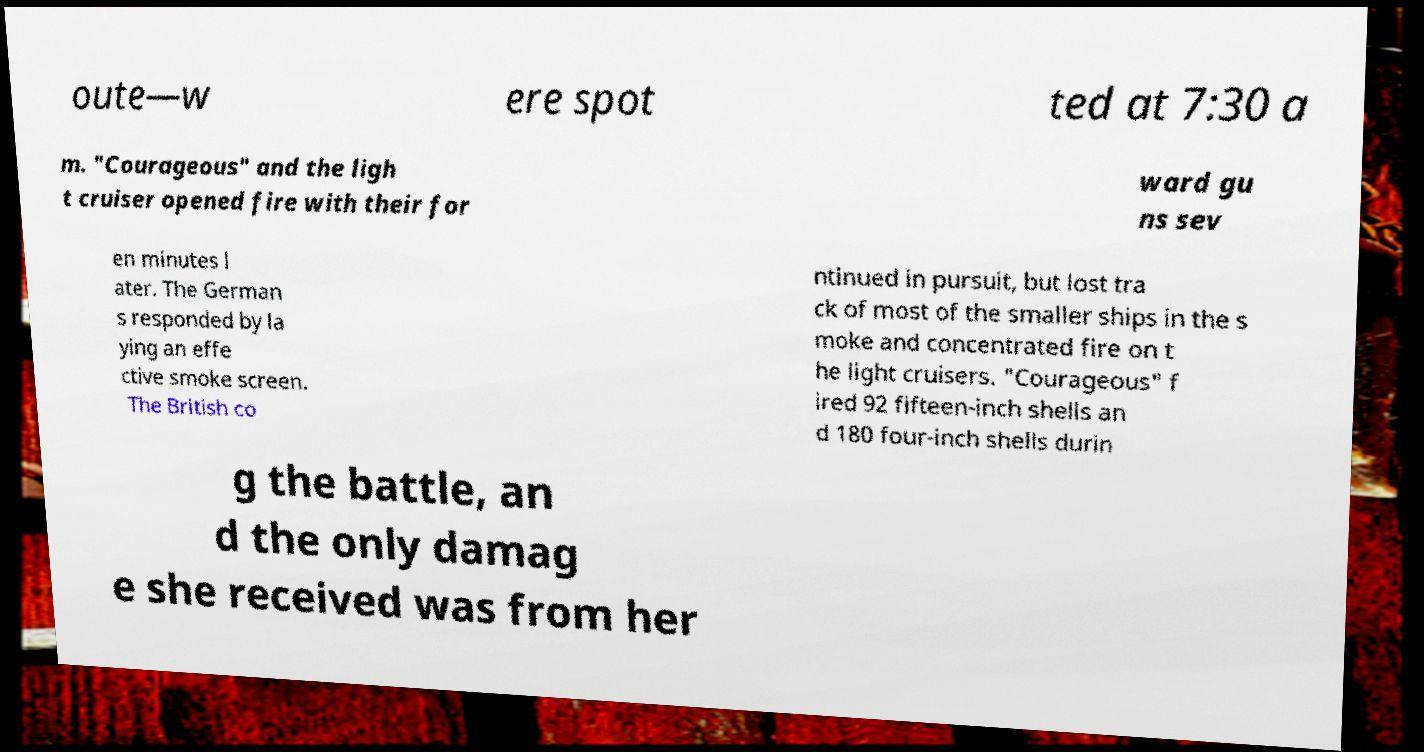Could you extract and type out the text from this image? oute—w ere spot ted at 7:30 a m. "Courageous" and the ligh t cruiser opened fire with their for ward gu ns sev en minutes l ater. The German s responded by la ying an effe ctive smoke screen. The British co ntinued in pursuit, but lost tra ck of most of the smaller ships in the s moke and concentrated fire on t he light cruisers. "Courageous" f ired 92 fifteen-inch shells an d 180 four-inch shells durin g the battle, an d the only damag e she received was from her 